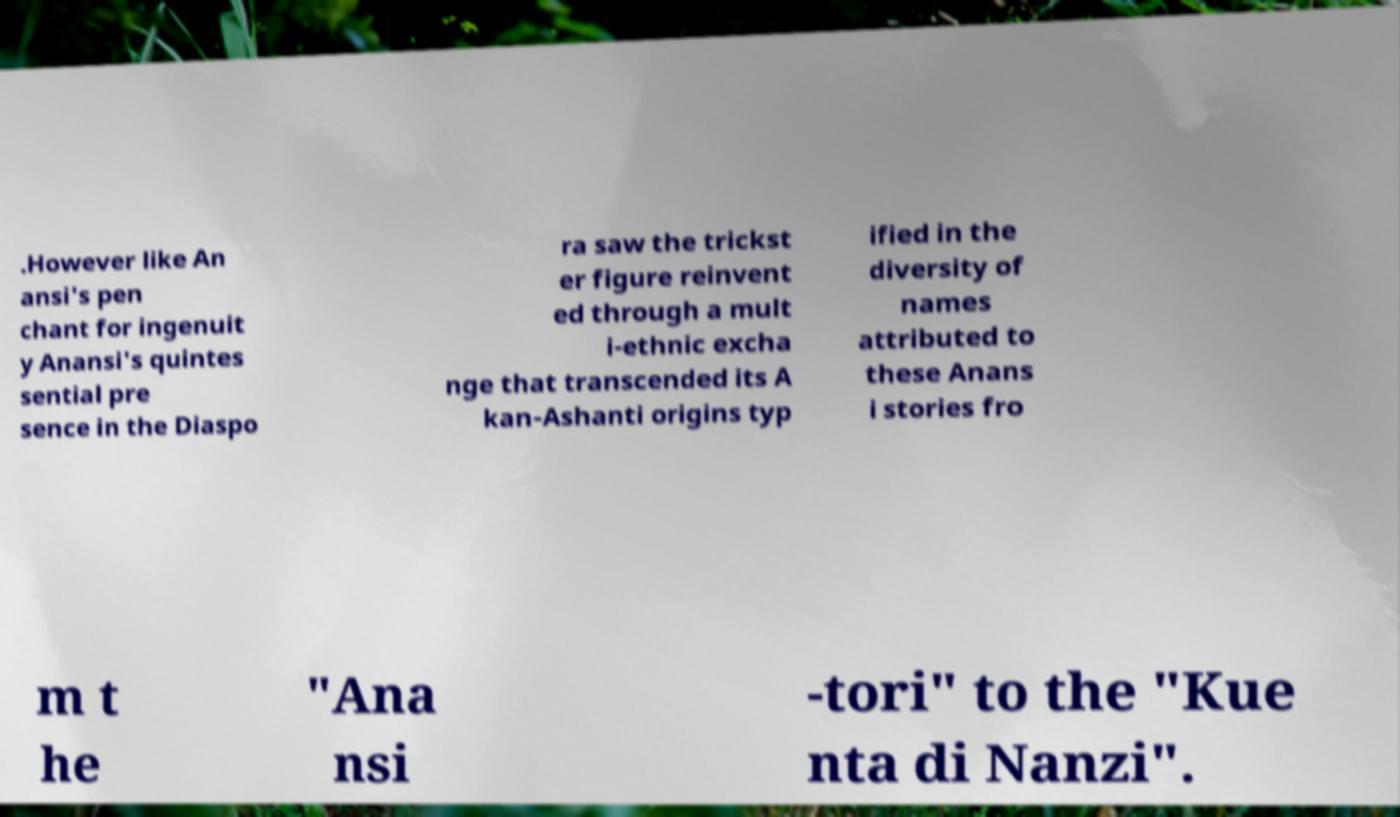Please identify and transcribe the text found in this image. .However like An ansi's pen chant for ingenuit y Anansi's quintes sential pre sence in the Diaspo ra saw the trickst er figure reinvent ed through a mult i-ethnic excha nge that transcended its A kan-Ashanti origins typ ified in the diversity of names attributed to these Anans i stories fro m t he "Ana nsi -tori" to the "Kue nta di Nanzi". 